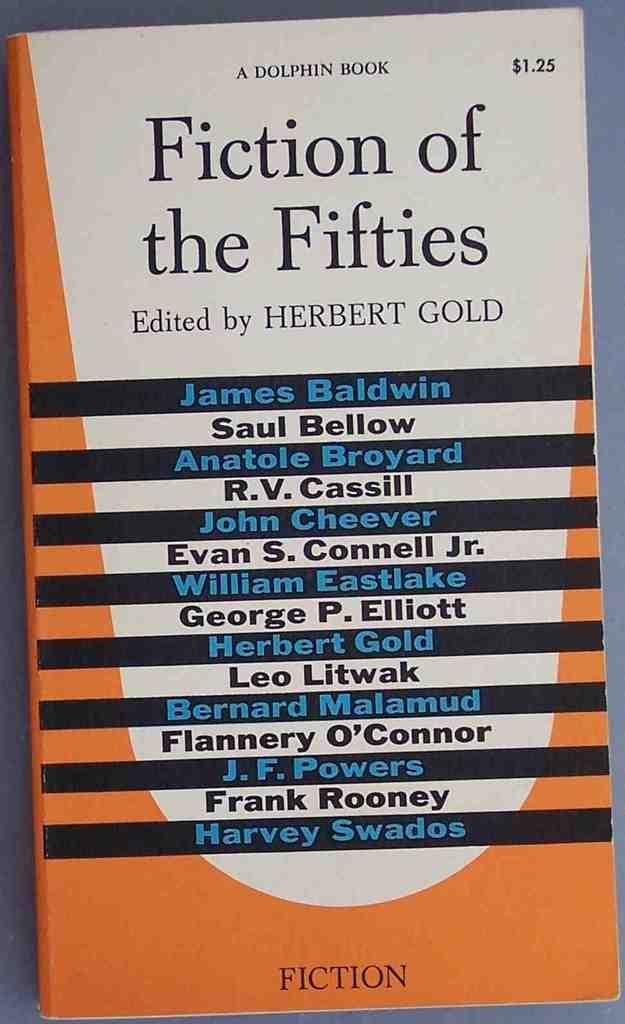Provide a one-sentence caption for the provided image. A book cover bears the title Fiction of the Fifties and lists various authors. 